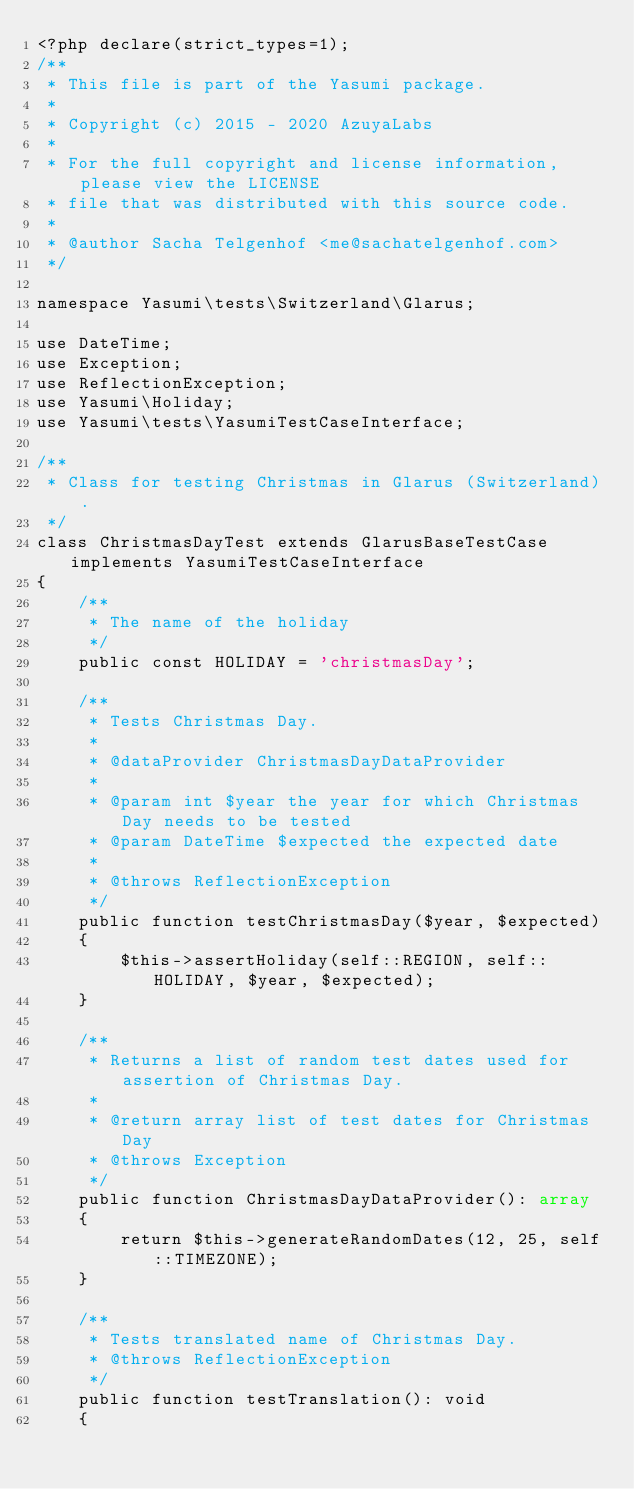Convert code to text. <code><loc_0><loc_0><loc_500><loc_500><_PHP_><?php declare(strict_types=1);
/**
 * This file is part of the Yasumi package.
 *
 * Copyright (c) 2015 - 2020 AzuyaLabs
 *
 * For the full copyright and license information, please view the LICENSE
 * file that was distributed with this source code.
 *
 * @author Sacha Telgenhof <me@sachatelgenhof.com>
 */

namespace Yasumi\tests\Switzerland\Glarus;

use DateTime;
use Exception;
use ReflectionException;
use Yasumi\Holiday;
use Yasumi\tests\YasumiTestCaseInterface;

/**
 * Class for testing Christmas in Glarus (Switzerland).
 */
class ChristmasDayTest extends GlarusBaseTestCase implements YasumiTestCaseInterface
{
    /**
     * The name of the holiday
     */
    public const HOLIDAY = 'christmasDay';

    /**
     * Tests Christmas Day.
     *
     * @dataProvider ChristmasDayDataProvider
     *
     * @param int $year the year for which Christmas Day needs to be tested
     * @param DateTime $expected the expected date
     *
     * @throws ReflectionException
     */
    public function testChristmasDay($year, $expected)
    {
        $this->assertHoliday(self::REGION, self::HOLIDAY, $year, $expected);
    }

    /**
     * Returns a list of random test dates used for assertion of Christmas Day.
     *
     * @return array list of test dates for Christmas Day
     * @throws Exception
     */
    public function ChristmasDayDataProvider(): array
    {
        return $this->generateRandomDates(12, 25, self::TIMEZONE);
    }

    /**
     * Tests translated name of Christmas Day.
     * @throws ReflectionException
     */
    public function testTranslation(): void
    {</code> 